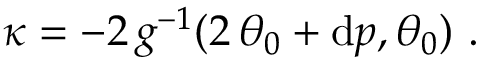<formula> <loc_0><loc_0><loc_500><loc_500>\kappa = - 2 \, g ^ { - 1 } ( 2 \, \theta _ { 0 } + d p , \theta _ { 0 } ) \ .</formula> 